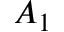<formula> <loc_0><loc_0><loc_500><loc_500>A _ { 1 }</formula> 